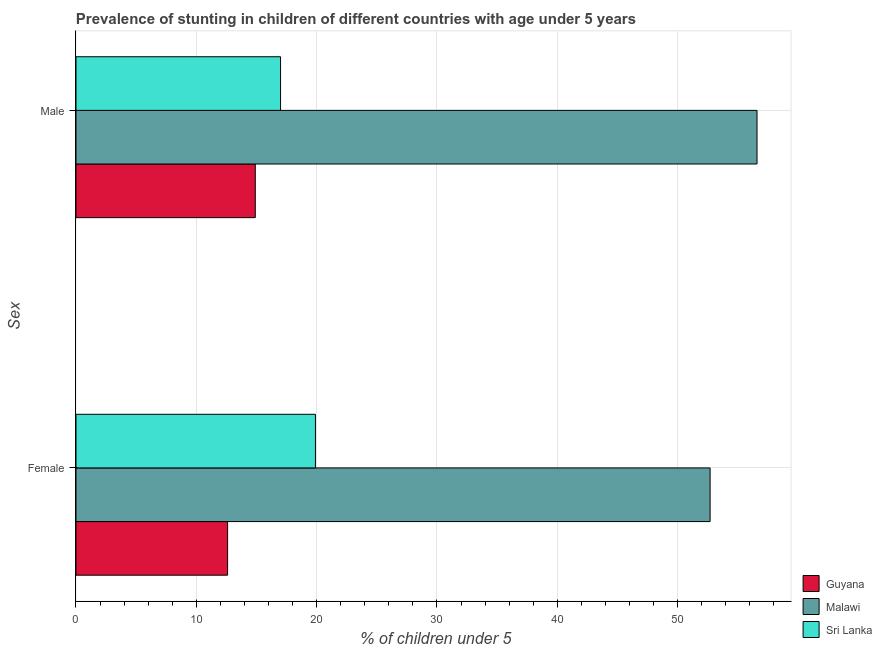How many groups of bars are there?
Your response must be concise. 2. How many bars are there on the 2nd tick from the bottom?
Make the answer very short. 3. What is the label of the 1st group of bars from the top?
Give a very brief answer. Male. What is the percentage of stunted female children in Malawi?
Ensure brevity in your answer.  52.7. Across all countries, what is the maximum percentage of stunted female children?
Provide a short and direct response. 52.7. Across all countries, what is the minimum percentage of stunted female children?
Offer a very short reply. 12.6. In which country was the percentage of stunted female children maximum?
Your answer should be compact. Malawi. In which country was the percentage of stunted male children minimum?
Your answer should be compact. Guyana. What is the total percentage of stunted female children in the graph?
Provide a succinct answer. 85.2. What is the difference between the percentage of stunted male children in Malawi and that in Guyana?
Offer a very short reply. 41.7. What is the difference between the percentage of stunted female children in Sri Lanka and the percentage of stunted male children in Guyana?
Your answer should be compact. 5. What is the average percentage of stunted female children per country?
Ensure brevity in your answer.  28.4. What is the difference between the percentage of stunted male children and percentage of stunted female children in Sri Lanka?
Offer a terse response. -2.9. In how many countries, is the percentage of stunted male children greater than 24 %?
Provide a succinct answer. 1. What is the ratio of the percentage of stunted female children in Malawi to that in Guyana?
Your response must be concise. 4.18. In how many countries, is the percentage of stunted male children greater than the average percentage of stunted male children taken over all countries?
Your answer should be compact. 1. What does the 1st bar from the top in Male represents?
Your response must be concise. Sri Lanka. What does the 2nd bar from the bottom in Female represents?
Provide a short and direct response. Malawi. Are all the bars in the graph horizontal?
Keep it short and to the point. Yes. How many countries are there in the graph?
Keep it short and to the point. 3. Are the values on the major ticks of X-axis written in scientific E-notation?
Keep it short and to the point. No. Does the graph contain any zero values?
Offer a terse response. No. Where does the legend appear in the graph?
Your response must be concise. Bottom right. How many legend labels are there?
Your answer should be compact. 3. What is the title of the graph?
Your answer should be very brief. Prevalence of stunting in children of different countries with age under 5 years. What is the label or title of the X-axis?
Give a very brief answer.  % of children under 5. What is the label or title of the Y-axis?
Provide a short and direct response. Sex. What is the  % of children under 5 in Guyana in Female?
Your answer should be compact. 12.6. What is the  % of children under 5 of Malawi in Female?
Your answer should be compact. 52.7. What is the  % of children under 5 in Sri Lanka in Female?
Your response must be concise. 19.9. What is the  % of children under 5 in Guyana in Male?
Your answer should be compact. 14.9. What is the  % of children under 5 in Malawi in Male?
Ensure brevity in your answer.  56.6. What is the  % of children under 5 of Sri Lanka in Male?
Your answer should be very brief. 17. Across all Sex, what is the maximum  % of children under 5 of Guyana?
Make the answer very short. 14.9. Across all Sex, what is the maximum  % of children under 5 of Malawi?
Ensure brevity in your answer.  56.6. Across all Sex, what is the maximum  % of children under 5 in Sri Lanka?
Ensure brevity in your answer.  19.9. Across all Sex, what is the minimum  % of children under 5 of Guyana?
Your answer should be very brief. 12.6. Across all Sex, what is the minimum  % of children under 5 of Malawi?
Your answer should be compact. 52.7. What is the total  % of children under 5 of Malawi in the graph?
Give a very brief answer. 109.3. What is the total  % of children under 5 of Sri Lanka in the graph?
Your response must be concise. 36.9. What is the difference between the  % of children under 5 of Malawi in Female and that in Male?
Give a very brief answer. -3.9. What is the difference between the  % of children under 5 of Guyana in Female and the  % of children under 5 of Malawi in Male?
Your answer should be very brief. -44. What is the difference between the  % of children under 5 in Malawi in Female and the  % of children under 5 in Sri Lanka in Male?
Your answer should be very brief. 35.7. What is the average  % of children under 5 of Guyana per Sex?
Keep it short and to the point. 13.75. What is the average  % of children under 5 in Malawi per Sex?
Ensure brevity in your answer.  54.65. What is the average  % of children under 5 in Sri Lanka per Sex?
Offer a terse response. 18.45. What is the difference between the  % of children under 5 of Guyana and  % of children under 5 of Malawi in Female?
Make the answer very short. -40.1. What is the difference between the  % of children under 5 in Guyana and  % of children under 5 in Sri Lanka in Female?
Provide a succinct answer. -7.3. What is the difference between the  % of children under 5 in Malawi and  % of children under 5 in Sri Lanka in Female?
Offer a very short reply. 32.8. What is the difference between the  % of children under 5 of Guyana and  % of children under 5 of Malawi in Male?
Give a very brief answer. -41.7. What is the difference between the  % of children under 5 in Malawi and  % of children under 5 in Sri Lanka in Male?
Your response must be concise. 39.6. What is the ratio of the  % of children under 5 of Guyana in Female to that in Male?
Ensure brevity in your answer.  0.85. What is the ratio of the  % of children under 5 of Malawi in Female to that in Male?
Ensure brevity in your answer.  0.93. What is the ratio of the  % of children under 5 in Sri Lanka in Female to that in Male?
Your answer should be very brief. 1.17. What is the difference between the highest and the lowest  % of children under 5 in Malawi?
Provide a succinct answer. 3.9. What is the difference between the highest and the lowest  % of children under 5 in Sri Lanka?
Provide a short and direct response. 2.9. 